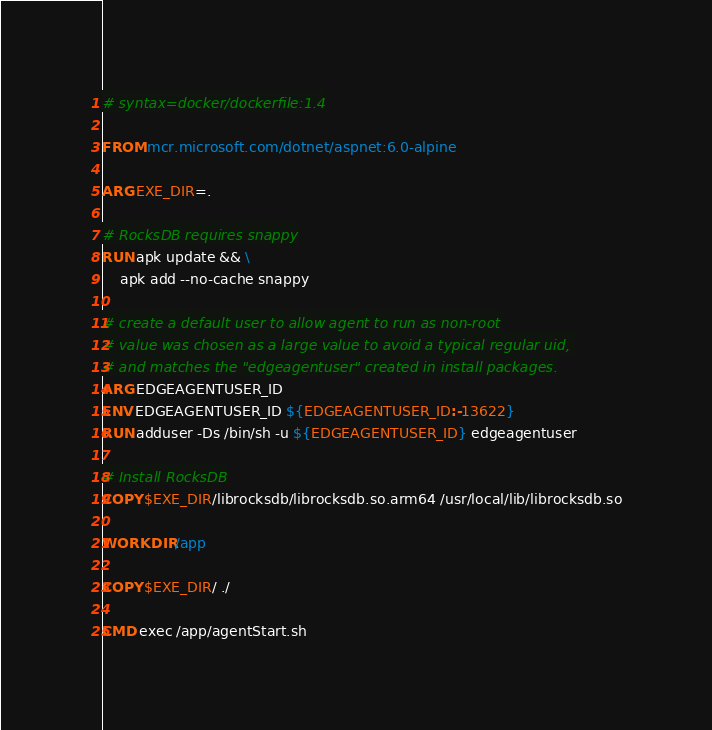<code> <loc_0><loc_0><loc_500><loc_500><_Dockerfile_># syntax=docker/dockerfile:1.4

FROM mcr.microsoft.com/dotnet/aspnet:6.0-alpine

ARG EXE_DIR=.

# RocksDB requires snappy
RUN apk update && \
    apk add --no-cache snappy

# create a default user to allow agent to run as non-root
# value was chosen as a large value to avoid a typical regular uid, 
# and matches the "edgeagentuser" created in install packages.
ARG EDGEAGENTUSER_ID
ENV EDGEAGENTUSER_ID ${EDGEAGENTUSER_ID:-13622}
RUN adduser -Ds /bin/sh -u ${EDGEAGENTUSER_ID} edgeagentuser 

# Install RocksDB
COPY $EXE_DIR/librocksdb/librocksdb.so.arm64 /usr/local/lib/librocksdb.so

WORKDIR /app

COPY $EXE_DIR/ ./

CMD exec /app/agentStart.sh
</code> 